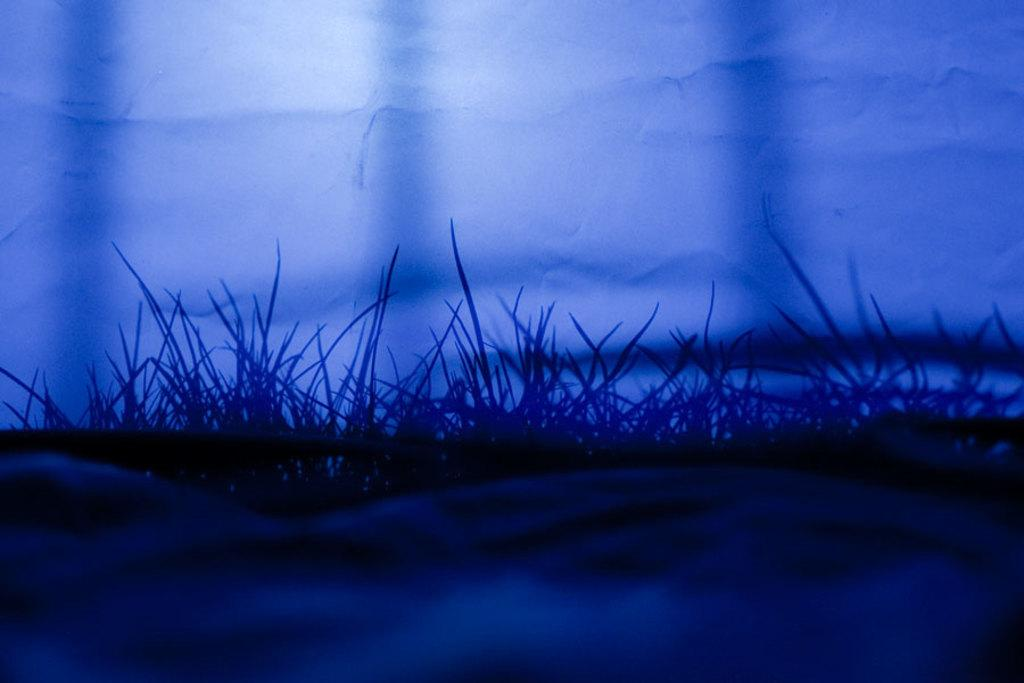What type of vegetation is present in the image? There is grass in the image. What else can be seen in the image related to the grass? There is a wall with the shadow of grass in the image. How would you describe the overall lighting in the image? The image is dark. How many children are playing with the pig in the image? There are no children or pigs present in the image; it only features grass and a wall with the shadow of grass. 